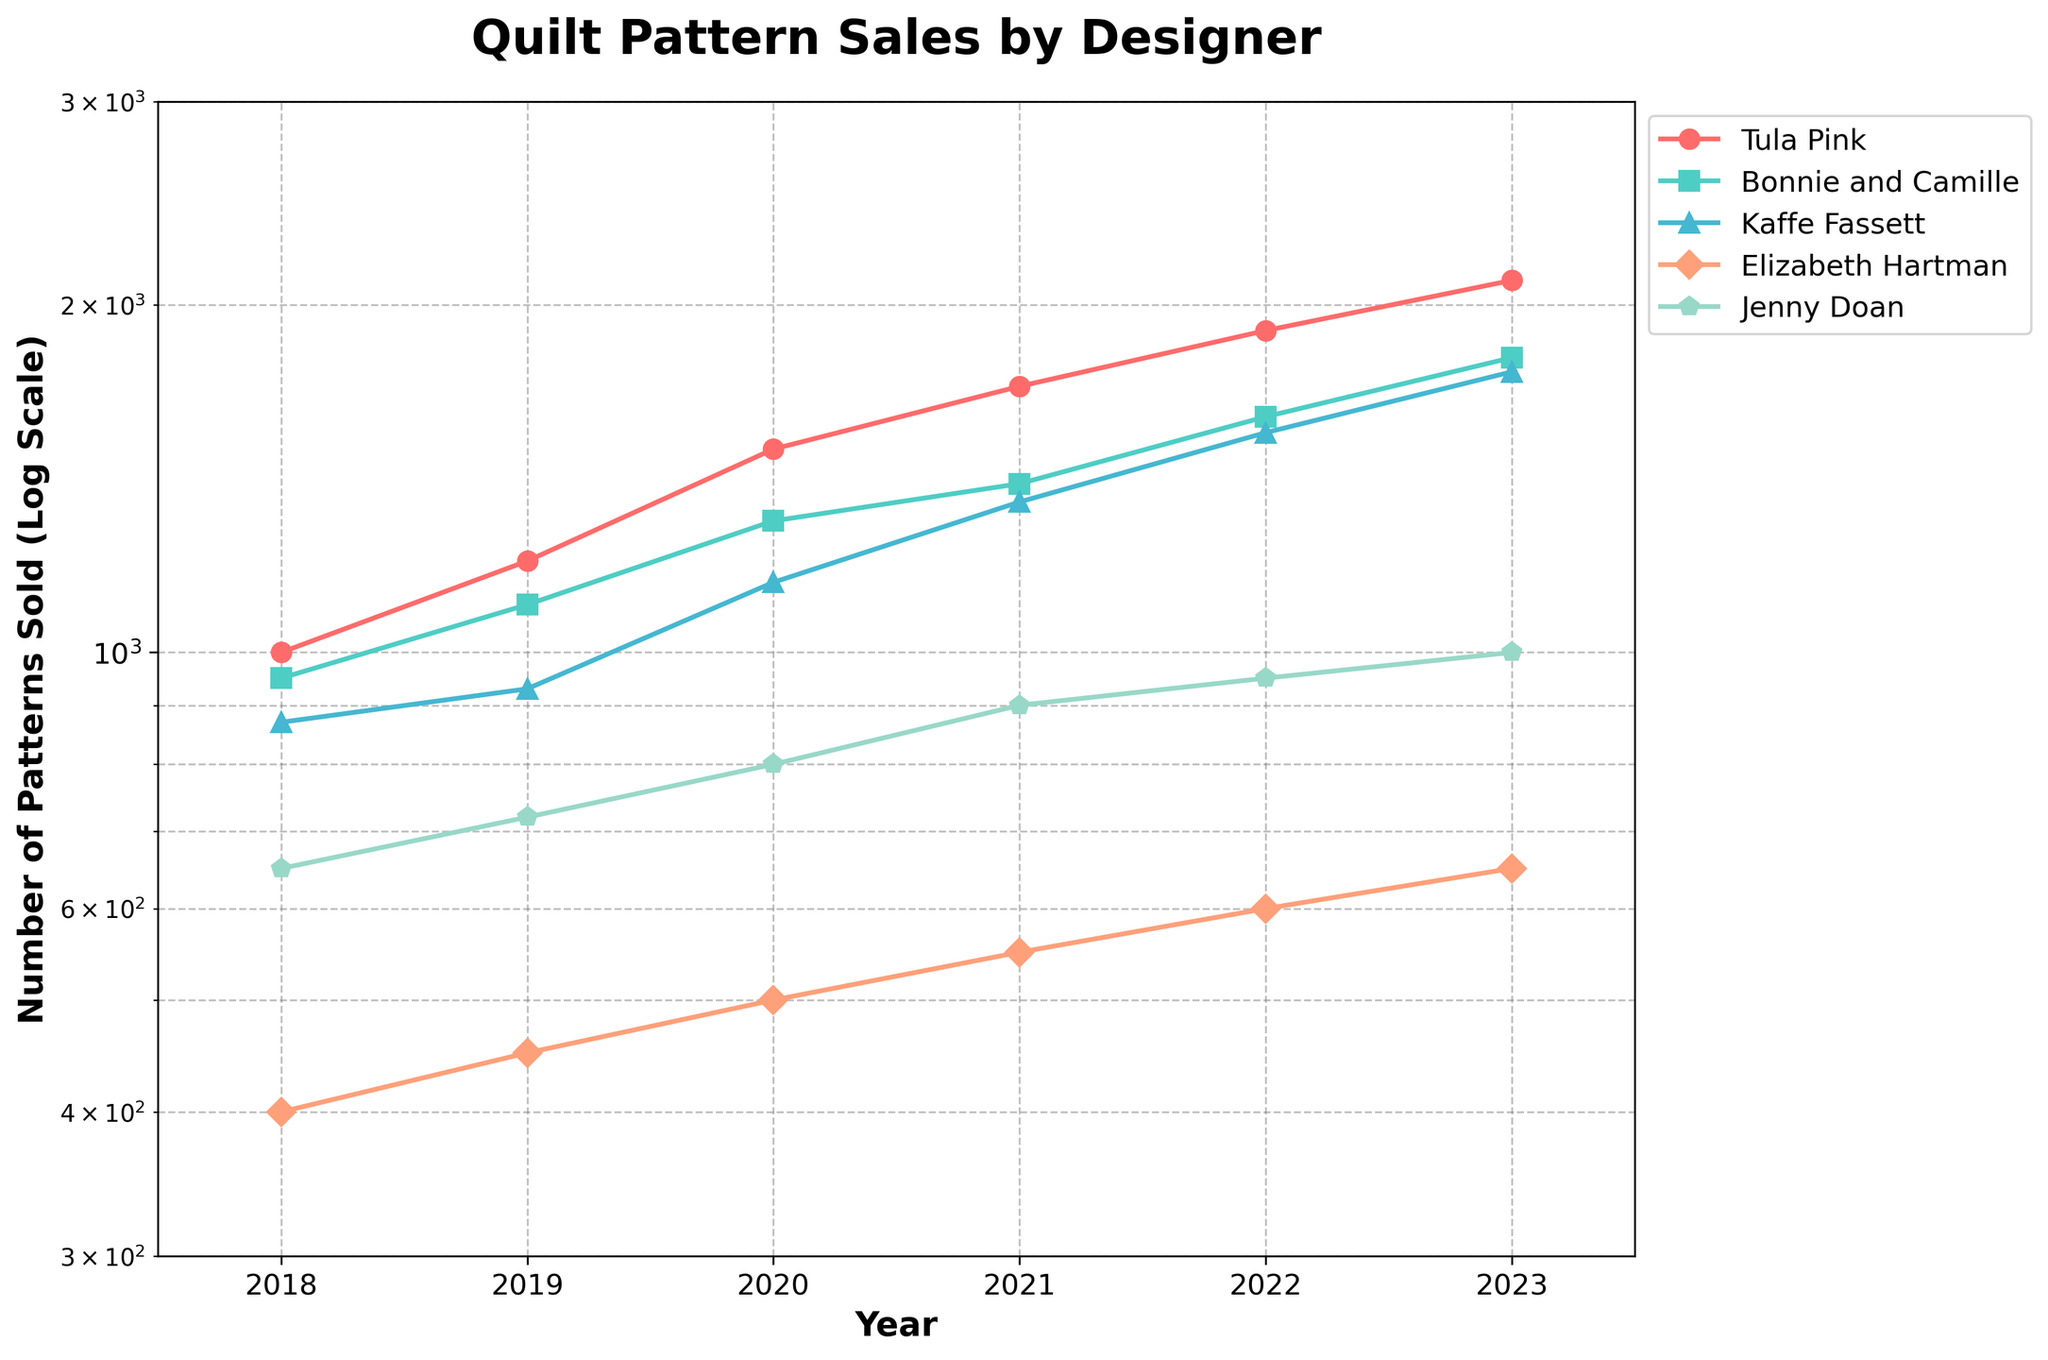What is the title of the plot? The title is written at the top of the plot and provides a summary of what the plot represents.
Answer: Quilt Pattern Sales by Designer How many pattern designers are included in the plot? The legend on the right side of the plot lists the pattern designers represented by different lines. By counting the labels in the legend, we can determine the number.
Answer: Five In which year did Tula Pink sell the most quilt patterns? By following the line labeled "Tula Pink" and looking for the highest point on the y-axis, we observe this occurs in 2023.
Answer: 2023 Which designer had the least number of patterns sold in 2018? Comparing the y-axis values for the year 2018 across all the designers, Elizabeth Hartman has the lowest value.
Answer: Elizabeth Hartman How do the sales trends for Jenny Doan and Kaffe Fassett compare from 2018 to 2023? By tracing the lines for Jenny Doan and Kaffe Fassett from 2018 to 2023, we observe that both designers show an upward trend in sales, but Jenny Doan's increase is more gradual compared to Kaffe Fassett's steeper rise.
Answer: Both trend upwards; Kaffe Fassett's trend is steeper What is the difference in sales between Bonnie and Camille and Elizabeth Hartman in 2021? The y-values for 2021 show Bonnie and Camille with approximately 1400 patterns sold and Elizabeth Hartman with around 550 patterns sold. The difference is calculated as 1400 - 550.
Answer: 850 What was the average number of patterns sold by Kaffe Fassett from 2018 to 2023? Adding the sales numbers for Kaffe Fassett from 2018 to 2023 (870 + 930 + 1150 + 1350 + 1550 + 1750) and dividing by the number of years (6) gives the average.
Answer: 1266.67 Which designer shows a consistent yearly increase in sales? By examining the sales trend lines, Tula Pink shows a consistent increase each year.
Answer: Tula Pink By what factor did Tula Pink's sales increase from 2018 to 2023? Using the log scale, Tula Pink's sales increased from 1000 in 2018 to 2100 in 2023. The factor can be calculated as 2100 / 1000.
Answer: 2.1 Which years show the greatest increase in sales for Elizabeth Hartman? By observing the steepness of the line representing Elizabeth Hartman, the largest increase is seen between 2022 and 2023.
Answer: 2022 to 2023 